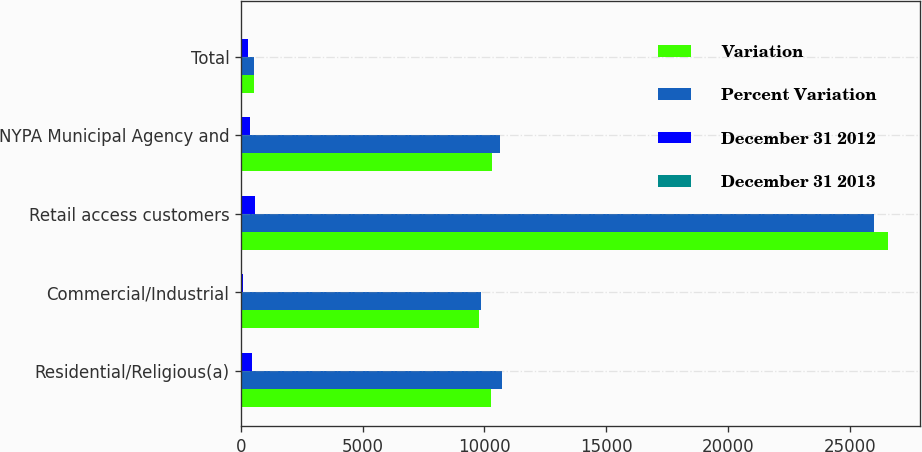Convert chart. <chart><loc_0><loc_0><loc_500><loc_500><stacked_bar_chart><ecel><fcel>Residential/Religious(a)<fcel>Commercial/Industrial<fcel>Retail access customers<fcel>NYPA Municipal Agency and<fcel>Total<nl><fcel>Variation<fcel>10273<fcel>9776<fcel>26574<fcel>10295<fcel>514.5<nl><fcel>Percent Variation<fcel>10718<fcel>9848<fcel>25990<fcel>10645<fcel>514.5<nl><fcel>December 31 2012<fcel>445<fcel>72<fcel>584<fcel>350<fcel>283<nl><fcel>December 31 2013<fcel>4.2<fcel>0.7<fcel>2.2<fcel>3.3<fcel>0.5<nl></chart> 